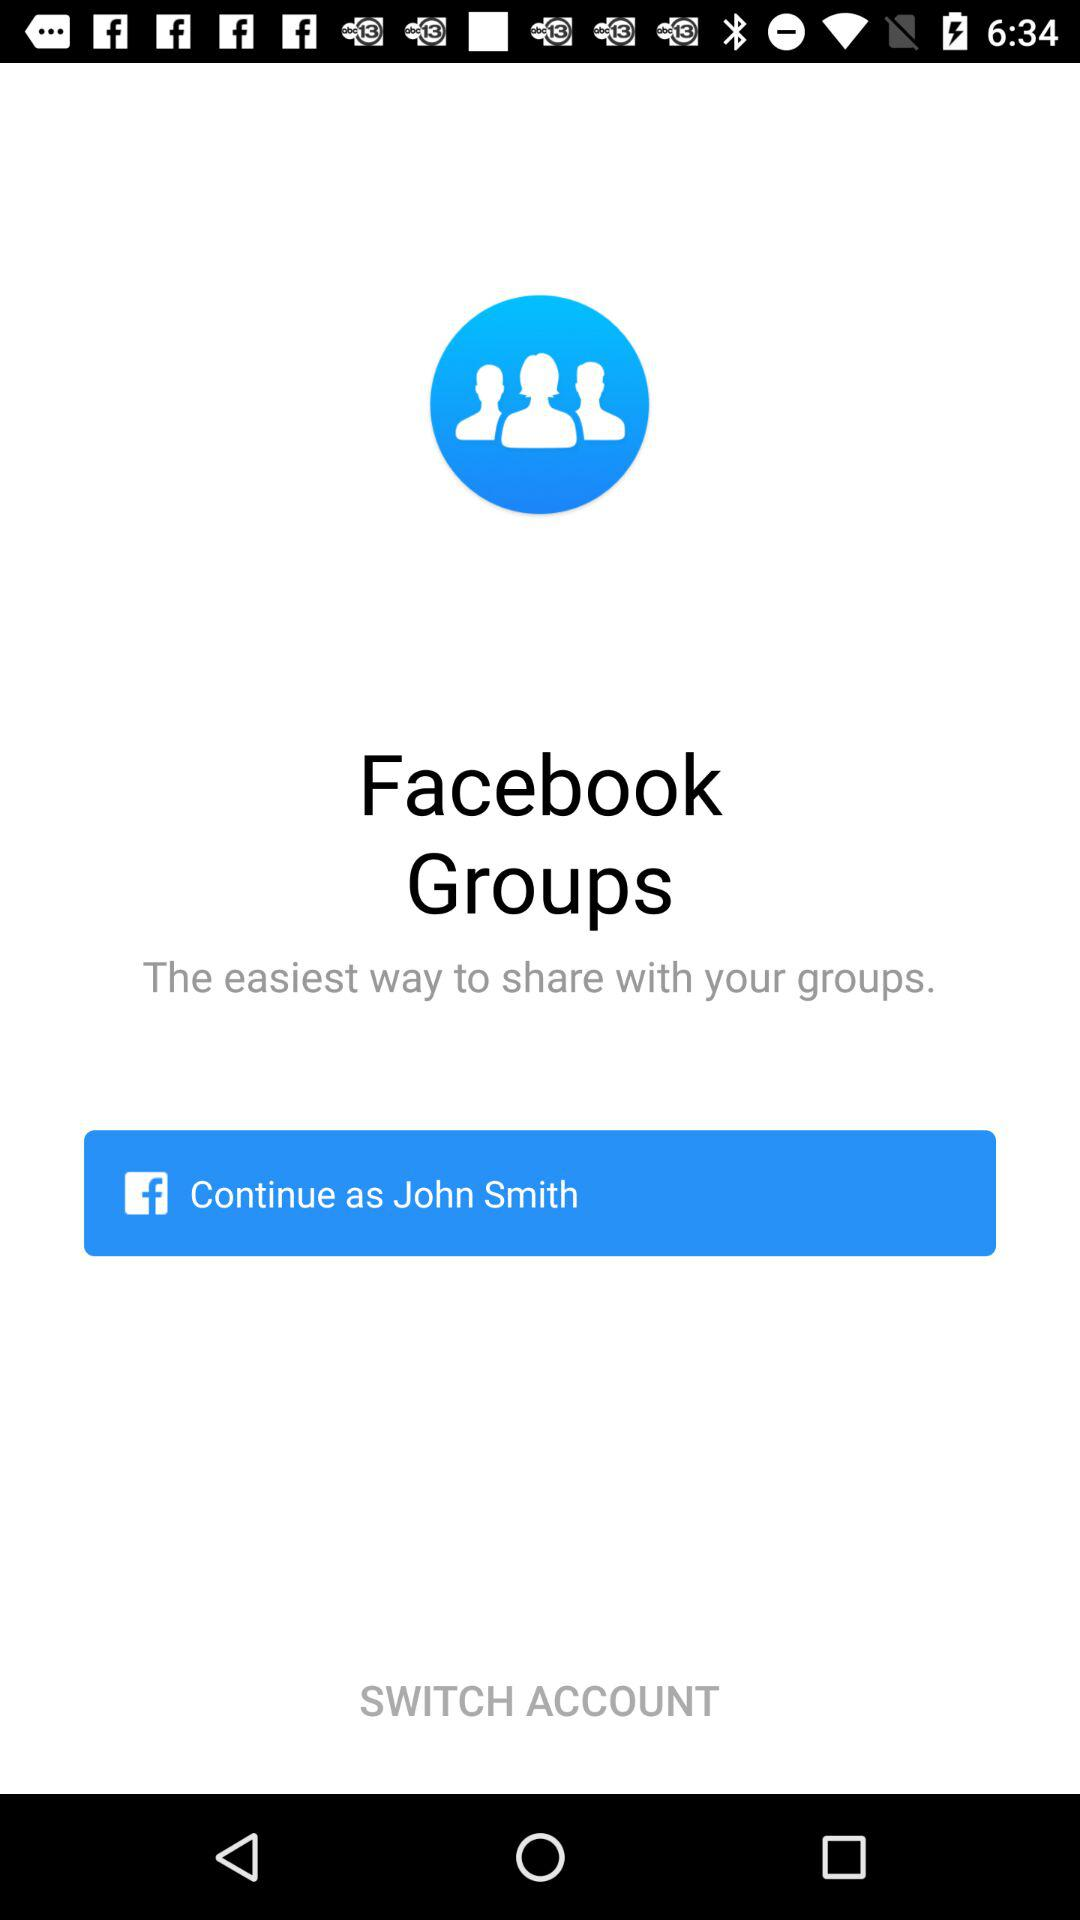What is the application name? The application name is "Facebook Groups". 